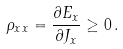Convert formula to latex. <formula><loc_0><loc_0><loc_500><loc_500>\rho _ { x x } = \frac { \partial E _ { x } } { \partial J _ { x } } \geq 0 \, .</formula> 